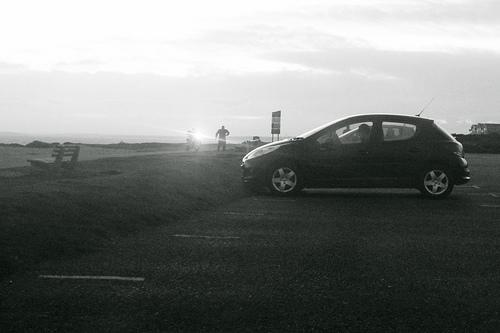Question: what is the light coming from?
Choices:
A. The sun.
B. The overhead lighting.
C. The light from the cell phone.
D. The moon.
Answer with the letter. Answer: A Question: how many cars are in the picture?
Choices:
A. 3.
B. 4.
C. 2.
D. 5.
Answer with the letter. Answer: C Question: what is the type of seat to the left?
Choices:
A. A hammock.
B. A couch.
C. A stool.
D. A bench.
Answer with the letter. Answer: D Question: when is the time of day?
Choices:
A. Afternoon.
B. Morning.
C. Sunset.
D. Late night.
Answer with the letter. Answer: C Question: who is in the first car?
Choices:
A. A policeman.
B. A celebrity.
C. The president.
D. A person.
Answer with the letter. Answer: D Question: what color is the road?
Choices:
A. Black.
B. White.
C. Gray.
D. Red.
Answer with the letter. Answer: A 